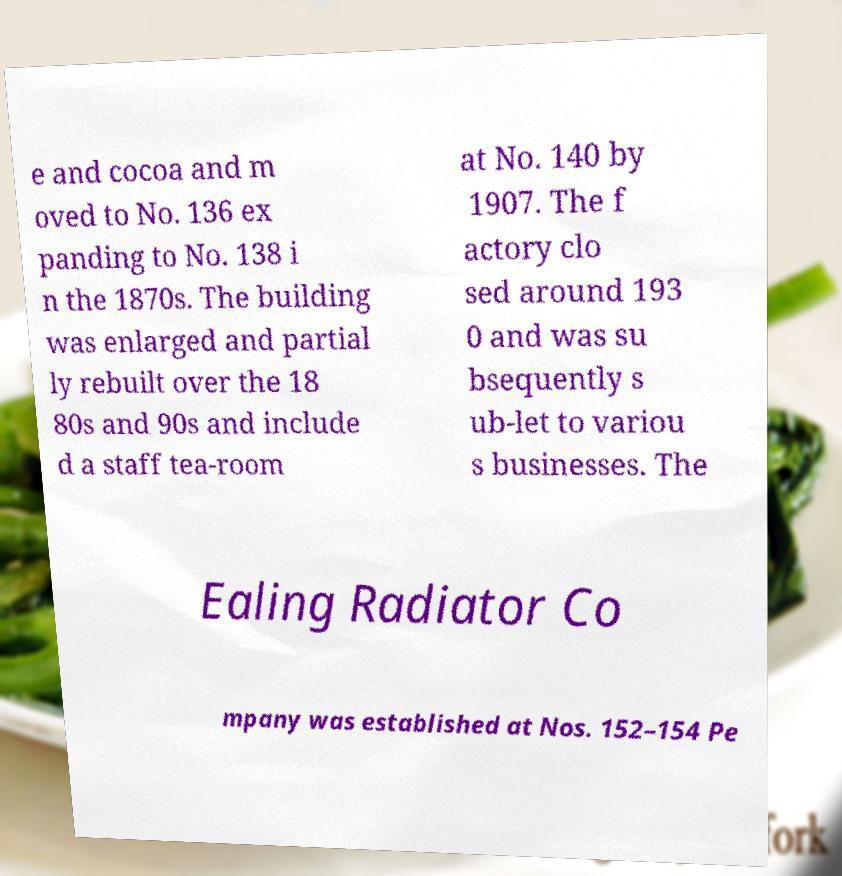Can you accurately transcribe the text from the provided image for me? e and cocoa and m oved to No. 136 ex panding to No. 138 i n the 1870s. The building was enlarged and partial ly rebuilt over the 18 80s and 90s and include d a staff tea-room at No. 140 by 1907. The f actory clo sed around 193 0 and was su bsequently s ub-let to variou s businesses. The Ealing Radiator Co mpany was established at Nos. 152–154 Pe 